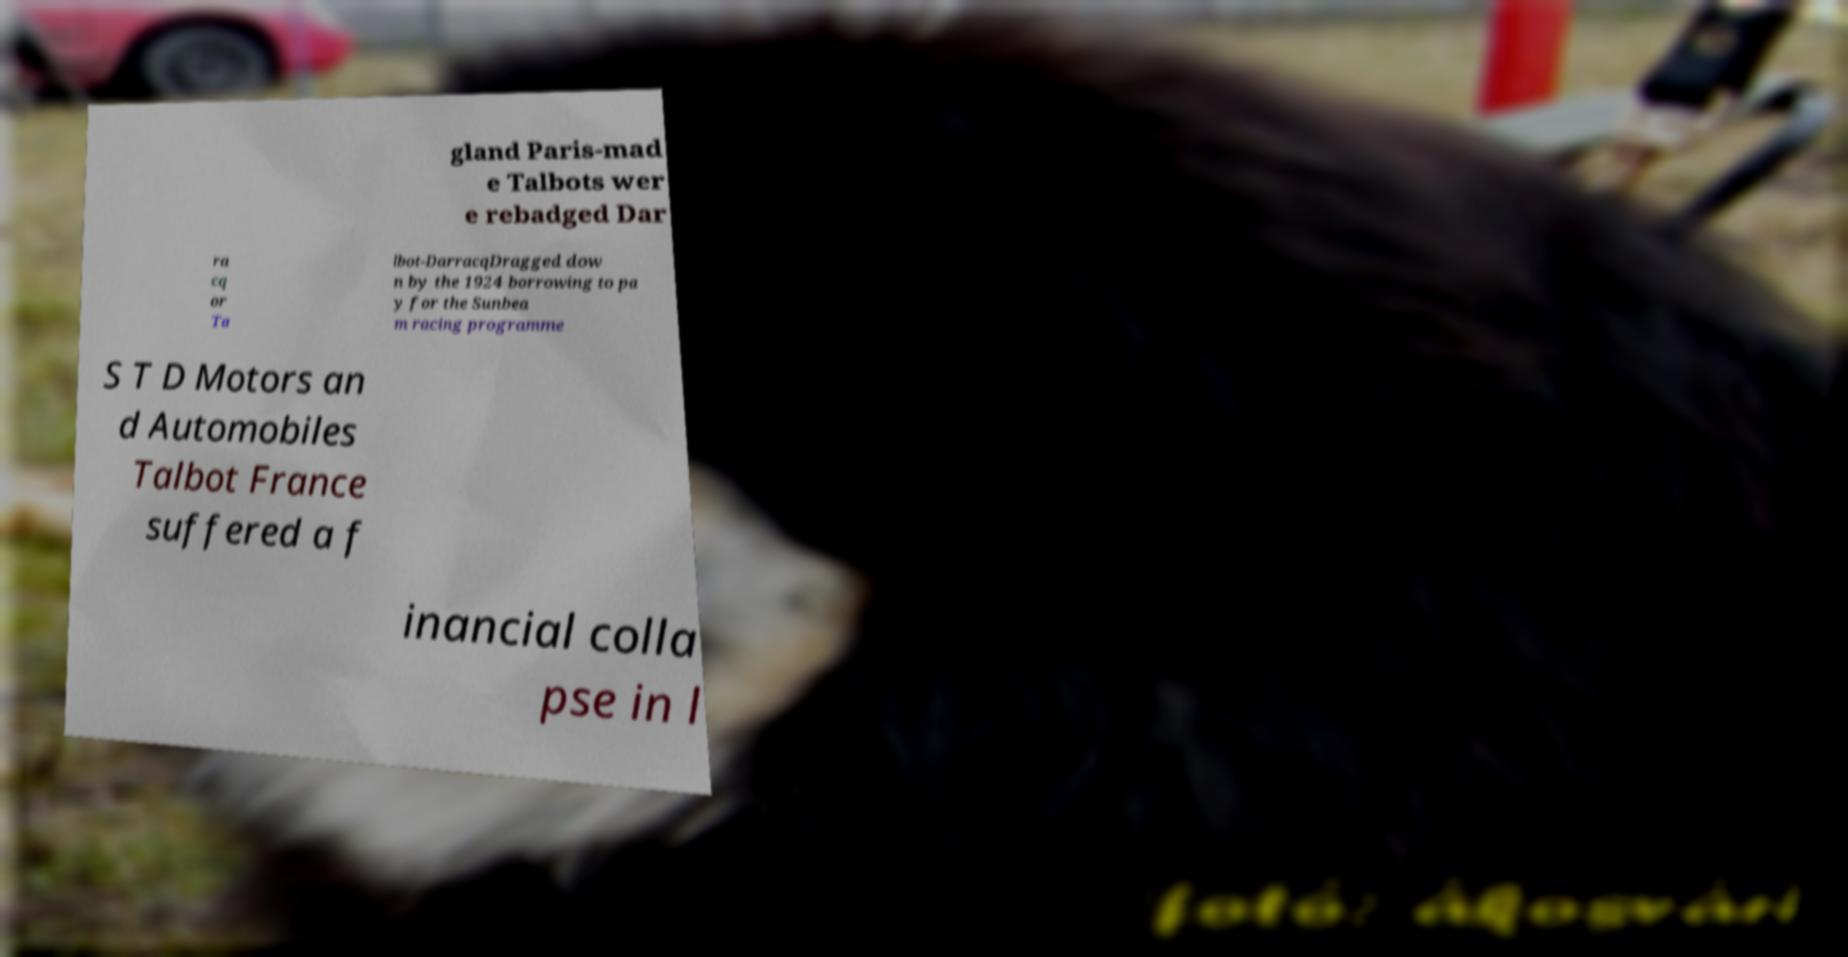There's text embedded in this image that I need extracted. Can you transcribe it verbatim? gland Paris-mad e Talbots wer e rebadged Dar ra cq or Ta lbot-DarracqDragged dow n by the 1924 borrowing to pa y for the Sunbea m racing programme S T D Motors an d Automobiles Talbot France suffered a f inancial colla pse in l 